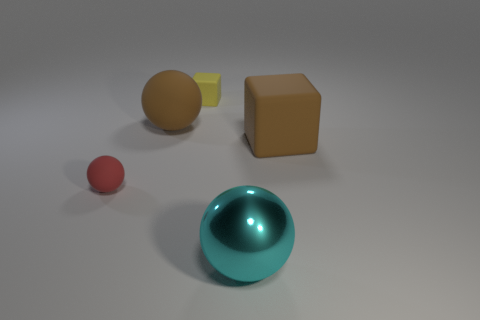Add 2 tiny red metallic cylinders. How many objects exist? 7 Subtract all blocks. How many objects are left? 3 Add 4 large brown blocks. How many large brown blocks are left? 5 Add 5 yellow matte objects. How many yellow matte objects exist? 6 Subtract 1 red balls. How many objects are left? 4 Subtract all small green metallic blocks. Subtract all metal balls. How many objects are left? 4 